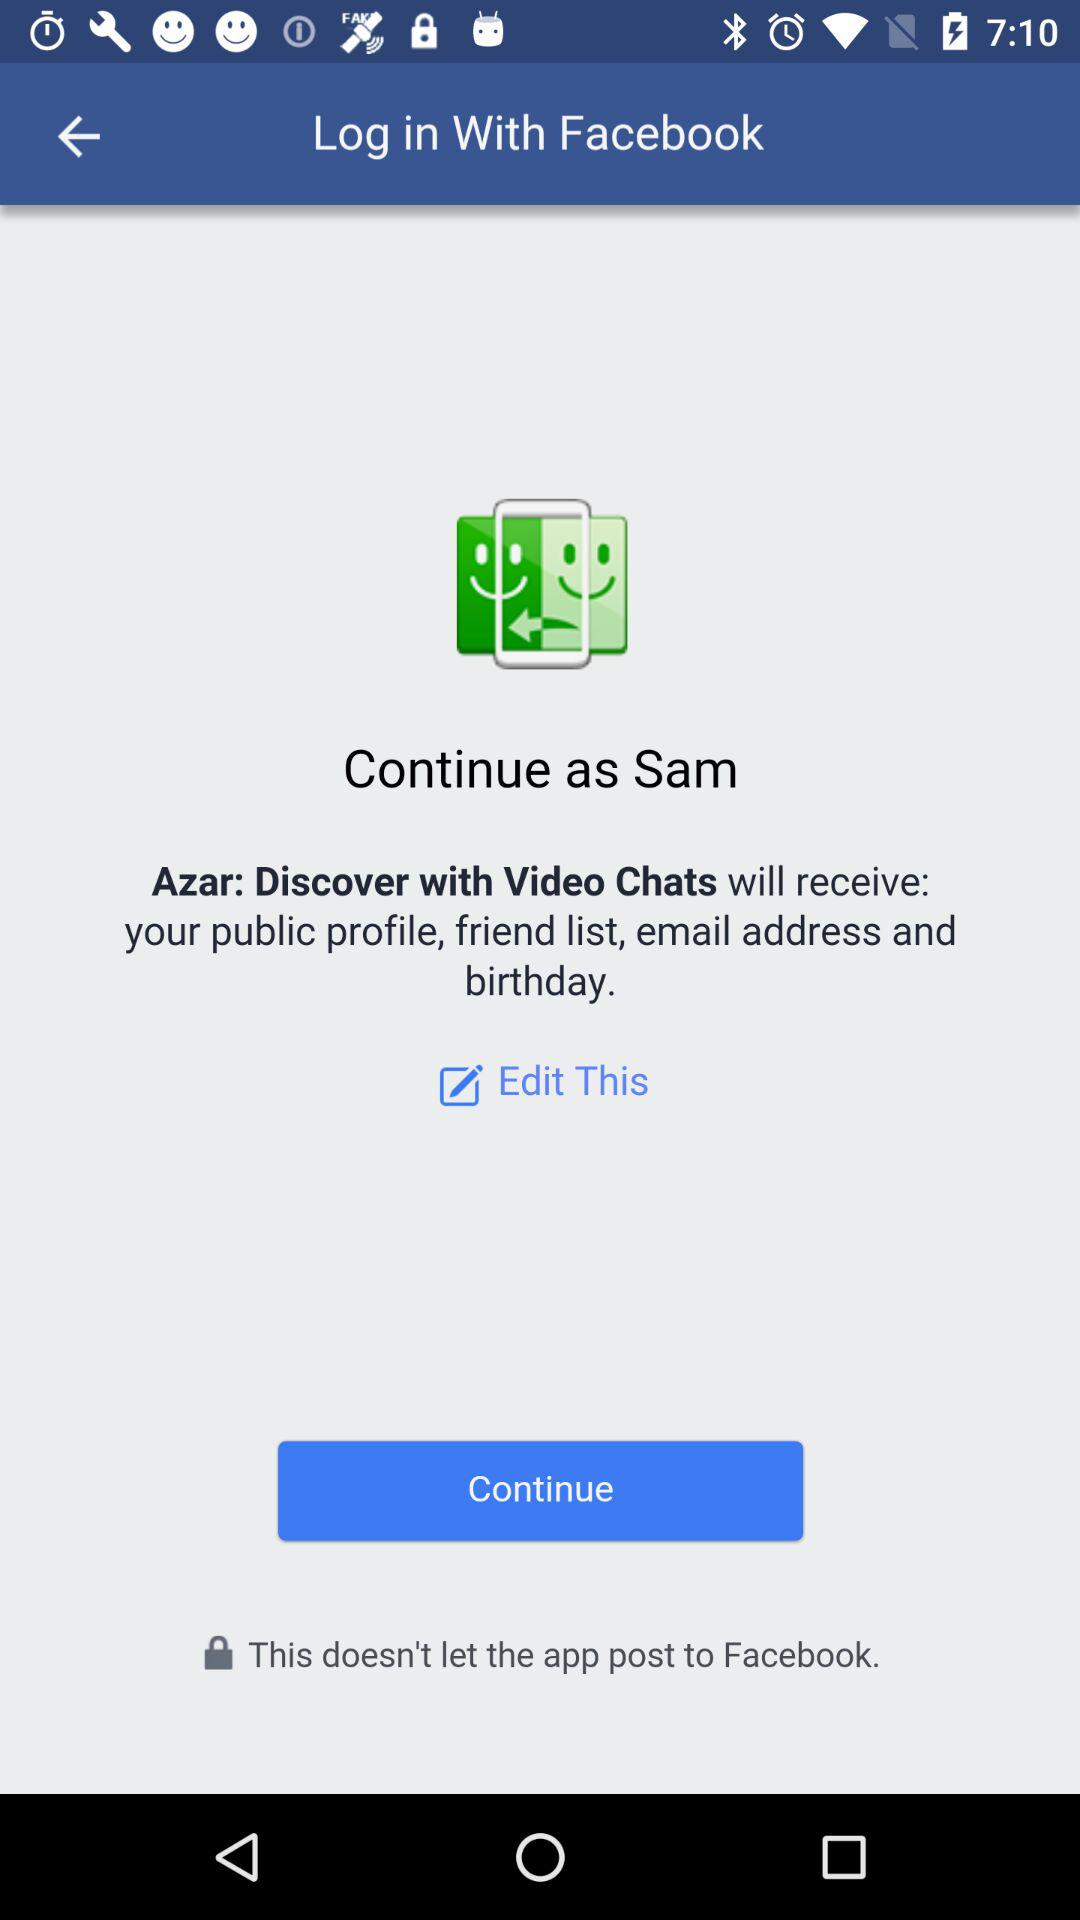What application is asking for permission? The application "Azar: Discover with Video Chats" is asking for permission. 